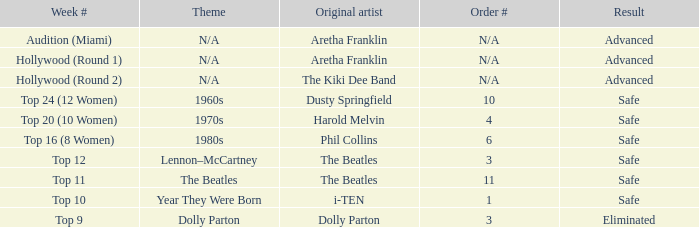What is the week number with Phil Collins as the original artist? Top 16 (8 Women). 